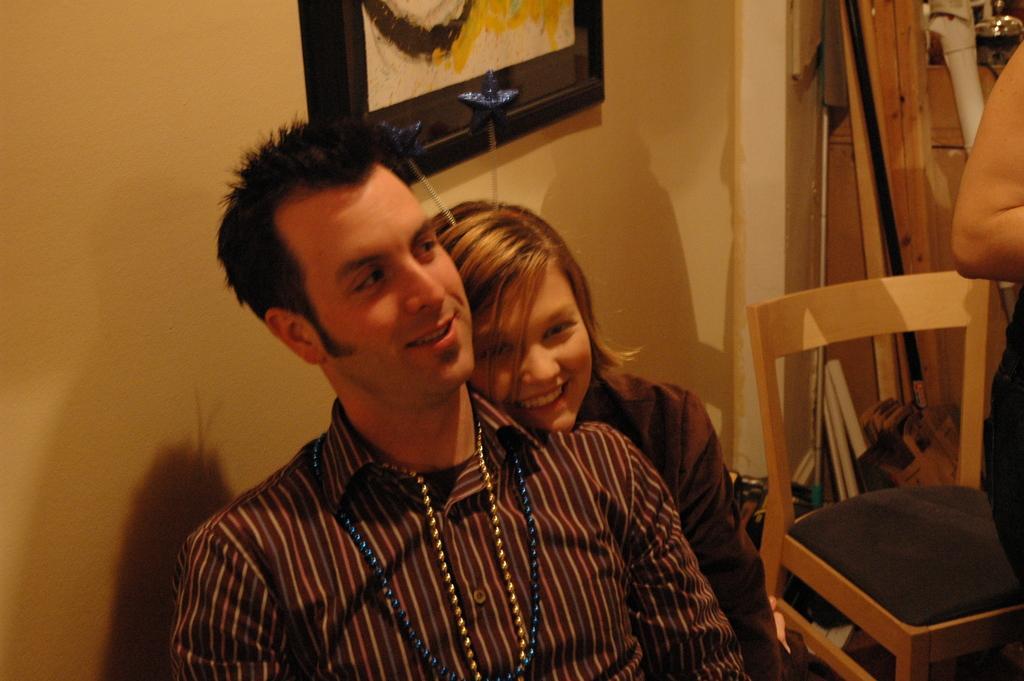Can you describe this image briefly? In this image there is a man towards the bottom of the image, there is a girl towards the bottom of the image, there is a person towards the right of the image, there is a chair towards the bottom of the image, there are objects towards the top of the image, there is a wall, there is a photo frame towards the top of the image. 